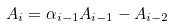Convert formula to latex. <formula><loc_0><loc_0><loc_500><loc_500>A _ { i } = \alpha _ { i - 1 } A _ { i - 1 } - A _ { i - 2 }</formula> 